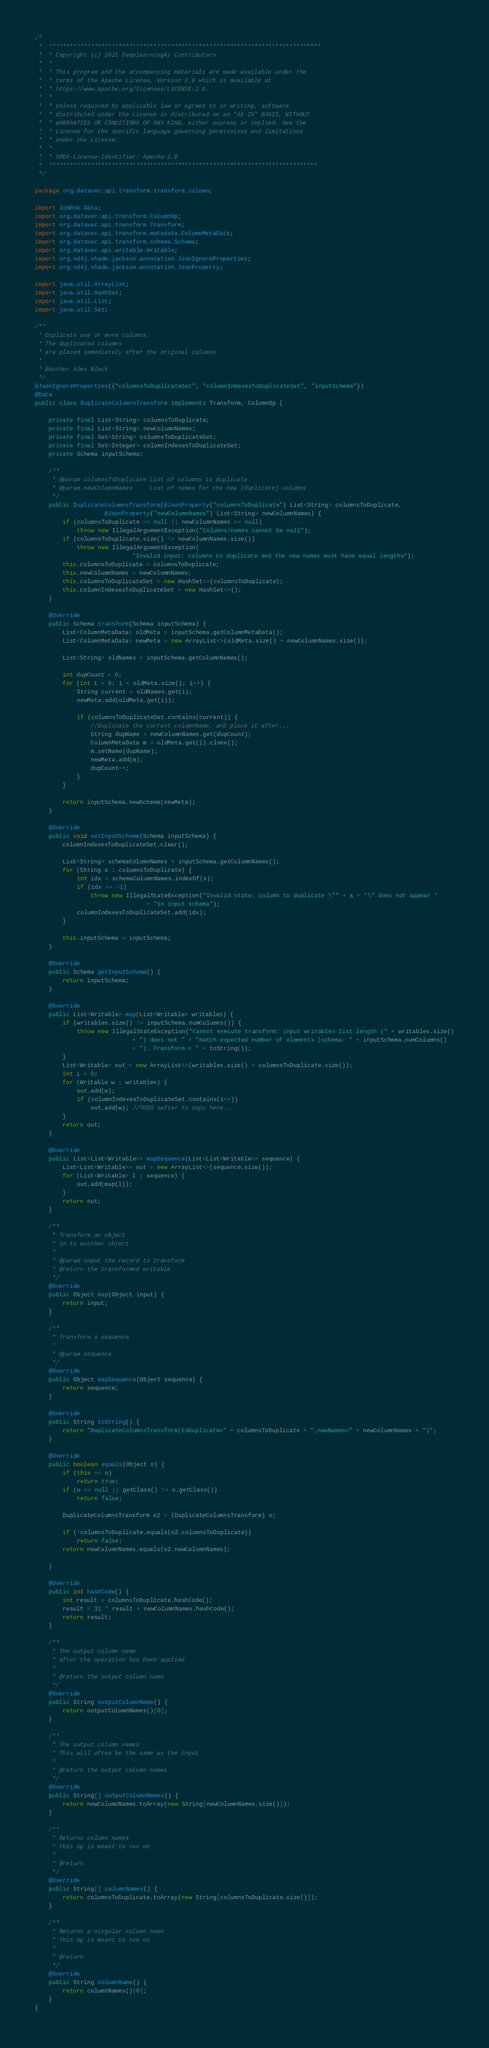Convert code to text. <code><loc_0><loc_0><loc_500><loc_500><_Java_>/*
 *  ******************************************************************************
 *  * Copyright (c) 2021 Deeplearning4j Contributors
 *  *
 *  * This program and the accompanying materials are made available under the
 *  * terms of the Apache License, Version 2.0 which is available at
 *  * https://www.apache.org/licenses/LICENSE-2.0.
 *  *
 *  * Unless required by applicable law or agreed to in writing, software
 *  * distributed under the License is distributed on an "AS IS" BASIS, WITHOUT
 *  * WARRANTIES OR CONDITIONS OF ANY KIND, either express or implied. See the
 *  * License for the specific language governing permissions and limitations
 *  * under the License.
 *  *
 *  * SPDX-License-Identifier: Apache-2.0
 *  *****************************************************************************
 */

package org.datavec.api.transform.transform.column;

import lombok.Data;
import org.datavec.api.transform.ColumnOp;
import org.datavec.api.transform.Transform;
import org.datavec.api.transform.metadata.ColumnMetaData;
import org.datavec.api.transform.schema.Schema;
import org.datavec.api.writable.Writable;
import org.nd4j.shade.jackson.annotation.JsonIgnoreProperties;
import org.nd4j.shade.jackson.annotation.JsonProperty;

import java.util.ArrayList;
import java.util.HashSet;
import java.util.List;
import java.util.Set;

/**
 * Duplicate one or more columns.
 * The duplicated columns
 * are placed immediately after the original columns
 *
 * @author Alex Black
 */
@JsonIgnoreProperties({"columnsToDuplicateSet", "columnIndexesToDuplicateSet", "inputSchema"})
@Data
public class DuplicateColumnsTransform implements Transform, ColumnOp {

    private final List<String> columnsToDuplicate;
    private final List<String> newColumnNames;
    private final Set<String> columnsToDuplicateSet;
    private final Set<Integer> columnIndexesToDuplicateSet;
    private Schema inputSchema;

    /**
     * @param columnsToDuplicate List of columns to duplicate
     * @param newColumnNames     List of names for the new (duplicate) columns
     */
    public DuplicateColumnsTransform(@JsonProperty("columnsToDuplicate") List<String> columnsToDuplicate,
                    @JsonProperty("newColumnNames") List<String> newColumnNames) {
        if (columnsToDuplicate == null || newColumnNames == null)
            throw new IllegalArgumentException("Columns/names cannot be null");
        if (columnsToDuplicate.size() != newColumnNames.size())
            throw new IllegalArgumentException(
                            "Invalid input: columns to duplicate and the new names must have equal lengths");
        this.columnsToDuplicate = columnsToDuplicate;
        this.newColumnNames = newColumnNames;
        this.columnsToDuplicateSet = new HashSet<>(columnsToDuplicate);
        this.columnIndexesToDuplicateSet = new HashSet<>();
    }

    @Override
    public Schema transform(Schema inputSchema) {
        List<ColumnMetaData> oldMeta = inputSchema.getColumnMetaData();
        List<ColumnMetaData> newMeta = new ArrayList<>(oldMeta.size() + newColumnNames.size());

        List<String> oldNames = inputSchema.getColumnNames();

        int dupCount = 0;
        for (int i = 0; i < oldMeta.size(); i++) {
            String current = oldNames.get(i);
            newMeta.add(oldMeta.get(i));

            if (columnsToDuplicateSet.contains(current)) {
                //Duplicate the current columnName, and place it after...
                String dupName = newColumnNames.get(dupCount);
                ColumnMetaData m = oldMeta.get(i).clone();
                m.setName(dupName);
                newMeta.add(m);
                dupCount++;
            }
        }

        return inputSchema.newSchema(newMeta);
    }

    @Override
    public void setInputSchema(Schema inputSchema) {
        columnIndexesToDuplicateSet.clear();

        List<String> schemaColumnNames = inputSchema.getColumnNames();
        for (String s : columnsToDuplicate) {
            int idx = schemaColumnNames.indexOf(s);
            if (idx == -1)
                throw new IllegalStateException("Invalid state: column to duplicate \"" + s + "\" does not appear "
                                + "in input schema");
            columnIndexesToDuplicateSet.add(idx);
        }

        this.inputSchema = inputSchema;
    }

    @Override
    public Schema getInputSchema() {
        return inputSchema;
    }

    @Override
    public List<Writable> map(List<Writable> writables) {
        if (writables.size() != inputSchema.numColumns()) {
            throw new IllegalStateException("Cannot execute transform: input writables list length (" + writables.size()
                            + ") does not " + "match expected number of elements (schema: " + inputSchema.numColumns()
                            + "). Transform = " + toString());
        }
        List<Writable> out = new ArrayList<>(writables.size() + columnsToDuplicate.size());
        int i = 0;
        for (Writable w : writables) {
            out.add(w);
            if (columnIndexesToDuplicateSet.contains(i++))
                out.add(w); //TODO safter to copy here...
        }
        return out;
    }

    @Override
    public List<List<Writable>> mapSequence(List<List<Writable>> sequence) {
        List<List<Writable>> out = new ArrayList<>(sequence.size());
        for (List<Writable> l : sequence) {
            out.add(map(l));
        }
        return out;
    }

    /**
     * Transform an object
     * in to another object
     *
     * @param input the record to transform
     * @return the transformed writable
     */
    @Override
    public Object map(Object input) {
        return input;
    }

    /**
     * Transform a sequence
     *
     * @param sequence
     */
    @Override
    public Object mapSequence(Object sequence) {
        return sequence;
    }

    @Override
    public String toString() {
        return "DuplicateColumnsTransform(toDuplicate=" + columnsToDuplicate + ",newNames=" + newColumnNames + ")";
    }

    @Override
    public boolean equals(Object o) {
        if (this == o)
            return true;
        if (o == null || getClass() != o.getClass())
            return false;

        DuplicateColumnsTransform o2 = (DuplicateColumnsTransform) o;

        if (!columnsToDuplicate.equals(o2.columnsToDuplicate))
            return false;
        return newColumnNames.equals(o2.newColumnNames);

    }

    @Override
    public int hashCode() {
        int result = columnsToDuplicate.hashCode();
        result = 31 * result + newColumnNames.hashCode();
        return result;
    }

    /**
     * The output column name
     * after the operation has been applied
     *
     * @return the output column name
     */
    @Override
    public String outputColumnName() {
        return outputColumnNames()[0];
    }

    /**
     * The output column names
     * This will often be the same as the input
     *
     * @return the output column names
     */
    @Override
    public String[] outputColumnNames() {
        return newColumnNames.toArray(new String[newColumnNames.size()]);
    }

    /**
     * Returns column names
     * this op is meant to run on
     *
     * @return
     */
    @Override
    public String[] columnNames() {
        return columnsToDuplicate.toArray(new String[columnsToDuplicate.size()]);
    }

    /**
     * Returns a singular column name
     * this op is meant to run on
     *
     * @return
     */
    @Override
    public String columnName() {
        return columnNames()[0];
    }
}
</code> 